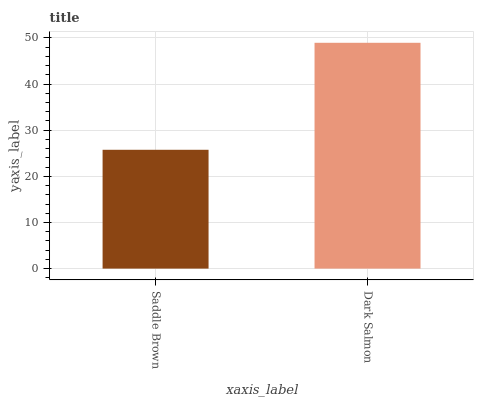Is Saddle Brown the minimum?
Answer yes or no. Yes. Is Dark Salmon the maximum?
Answer yes or no. Yes. Is Dark Salmon the minimum?
Answer yes or no. No. Is Dark Salmon greater than Saddle Brown?
Answer yes or no. Yes. Is Saddle Brown less than Dark Salmon?
Answer yes or no. Yes. Is Saddle Brown greater than Dark Salmon?
Answer yes or no. No. Is Dark Salmon less than Saddle Brown?
Answer yes or no. No. Is Dark Salmon the high median?
Answer yes or no. Yes. Is Saddle Brown the low median?
Answer yes or no. Yes. Is Saddle Brown the high median?
Answer yes or no. No. Is Dark Salmon the low median?
Answer yes or no. No. 